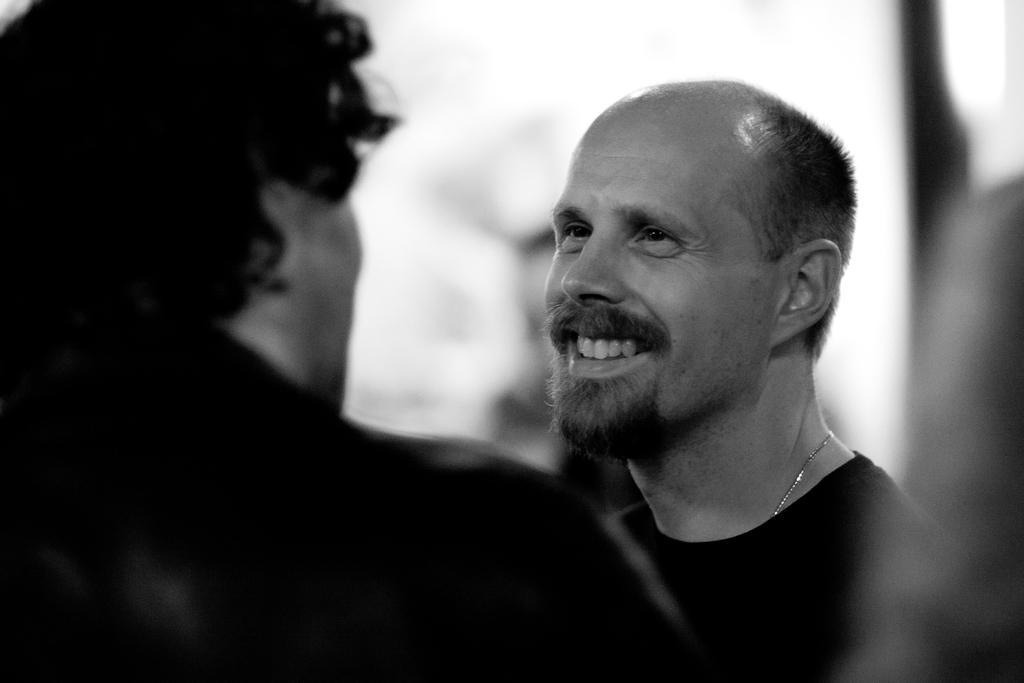How would you summarize this image in a sentence or two? This is a black and white picture. In this image, we can see a man smiling and watching another person. In the background and right side of the image, there is a blur view. 